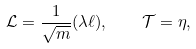<formula> <loc_0><loc_0><loc_500><loc_500>\mathcal { L } = \frac { 1 } { \sqrt { m } } ( \lambda \ell ) , \quad \mathcal { T } = \eta ,</formula> 